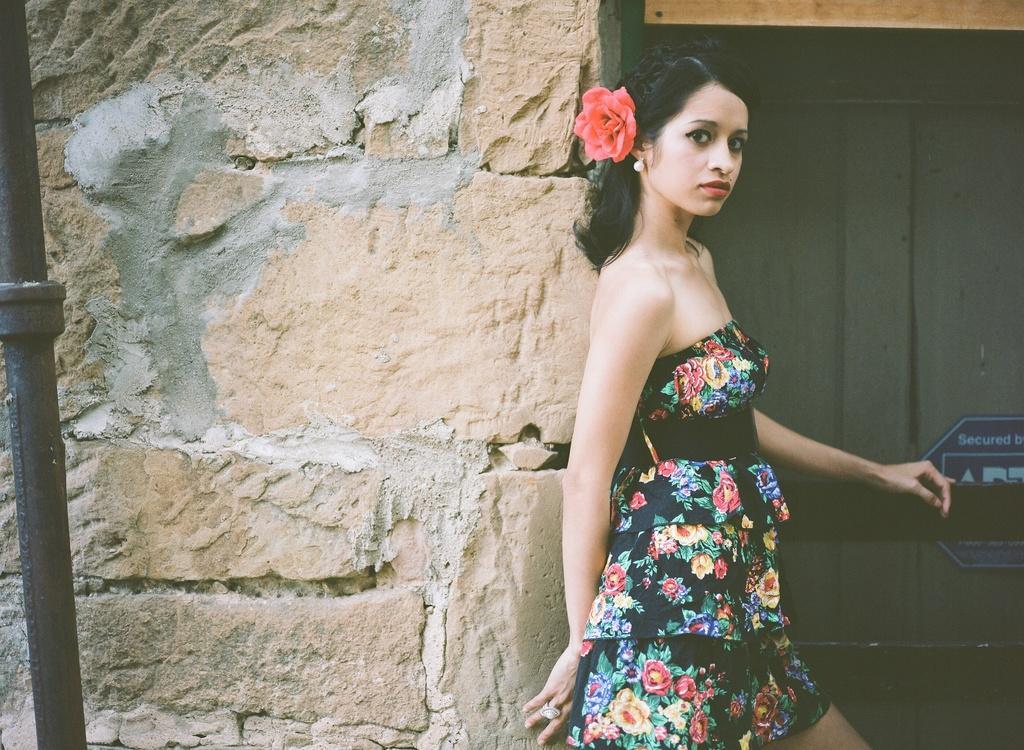Could you give a brief overview of what you see in this image? In this image we can see a woman standing near the wall, beside her there is a wooden object which looks like a door and a board attached to it. 